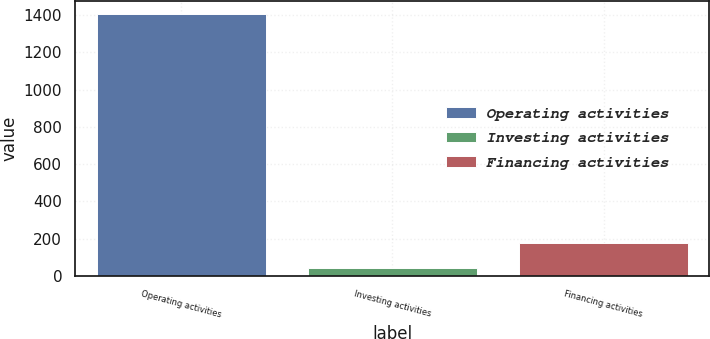Convert chart to OTSL. <chart><loc_0><loc_0><loc_500><loc_500><bar_chart><fcel>Operating activities<fcel>Investing activities<fcel>Financing activities<nl><fcel>1405<fcel>42<fcel>178.3<nl></chart> 